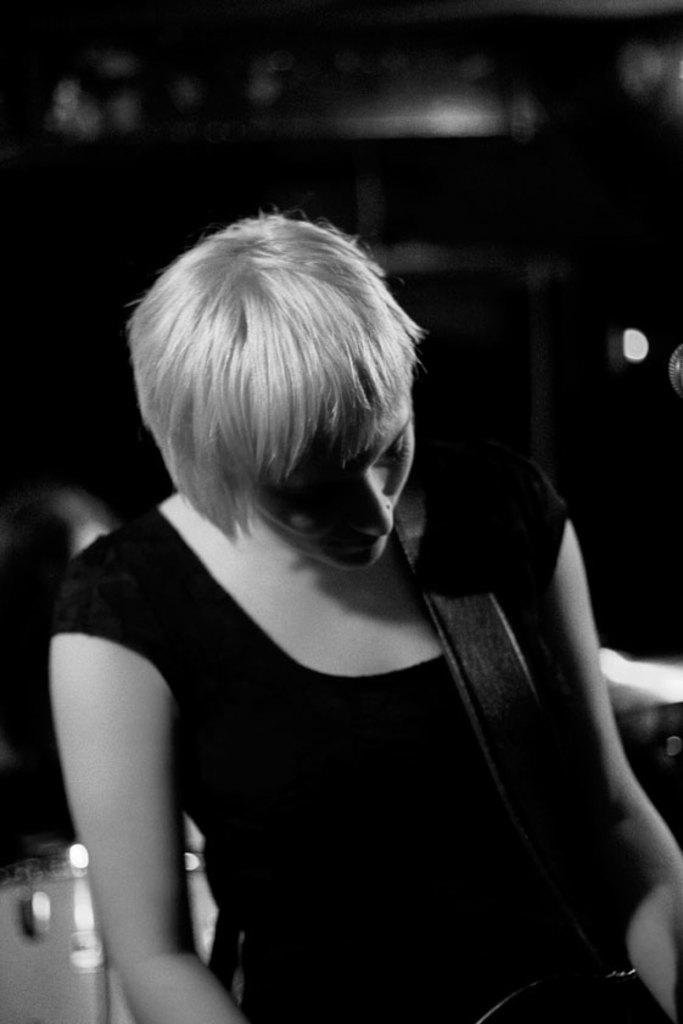Who is present in the image? There is a woman in the image. What is the woman doing in the image? The woman is carrying an object. What is the color scheme of the image? The image is in black and white. Can you describe the background of the image? The background of the image is blurry. What type of brass instrument can be seen in the woman's hand in the image? There is no brass instrument present in the image. What type of lace fabric is draped over the woman's shoulder in the image? There is no lace fabric present in the image. 